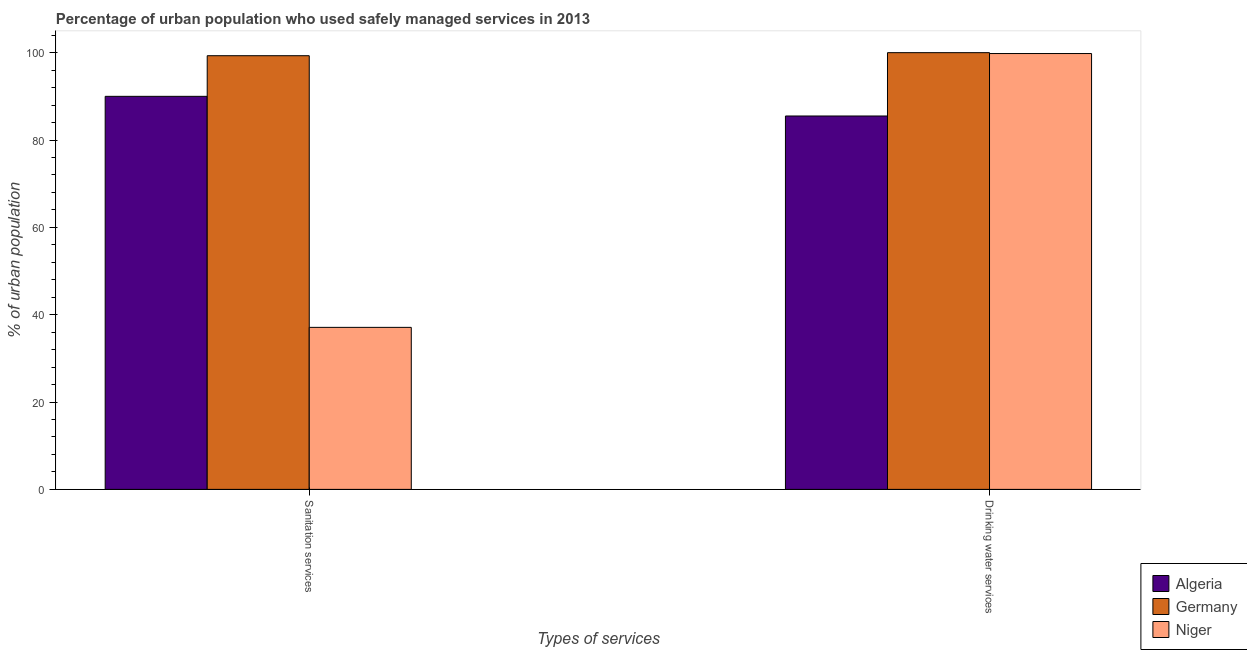How many groups of bars are there?
Make the answer very short. 2. Are the number of bars per tick equal to the number of legend labels?
Provide a short and direct response. Yes. How many bars are there on the 2nd tick from the right?
Ensure brevity in your answer.  3. What is the label of the 1st group of bars from the left?
Ensure brevity in your answer.  Sanitation services. What is the percentage of urban population who used sanitation services in Algeria?
Offer a terse response. 90. Across all countries, what is the maximum percentage of urban population who used sanitation services?
Provide a short and direct response. 99.3. Across all countries, what is the minimum percentage of urban population who used sanitation services?
Make the answer very short. 37.1. In which country was the percentage of urban population who used drinking water services maximum?
Make the answer very short. Germany. In which country was the percentage of urban population who used sanitation services minimum?
Ensure brevity in your answer.  Niger. What is the total percentage of urban population who used sanitation services in the graph?
Give a very brief answer. 226.4. What is the difference between the percentage of urban population who used drinking water services in Germany and that in Niger?
Give a very brief answer. 0.2. What is the difference between the percentage of urban population who used drinking water services in Niger and the percentage of urban population who used sanitation services in Algeria?
Provide a short and direct response. 9.8. What is the average percentage of urban population who used sanitation services per country?
Make the answer very short. 75.47. What is the ratio of the percentage of urban population who used drinking water services in Germany to that in Niger?
Your answer should be very brief. 1. What does the 1st bar from the right in Sanitation services represents?
Make the answer very short. Niger. Are all the bars in the graph horizontal?
Ensure brevity in your answer.  No. What is the difference between two consecutive major ticks on the Y-axis?
Your answer should be very brief. 20. Does the graph contain grids?
Keep it short and to the point. No. What is the title of the graph?
Provide a succinct answer. Percentage of urban population who used safely managed services in 2013. Does "Middle East & North Africa (all income levels)" appear as one of the legend labels in the graph?
Provide a short and direct response. No. What is the label or title of the X-axis?
Provide a short and direct response. Types of services. What is the label or title of the Y-axis?
Your answer should be very brief. % of urban population. What is the % of urban population in Algeria in Sanitation services?
Offer a terse response. 90. What is the % of urban population in Germany in Sanitation services?
Your answer should be very brief. 99.3. What is the % of urban population of Niger in Sanitation services?
Offer a terse response. 37.1. What is the % of urban population of Algeria in Drinking water services?
Make the answer very short. 85.5. What is the % of urban population of Germany in Drinking water services?
Your answer should be compact. 100. What is the % of urban population of Niger in Drinking water services?
Your response must be concise. 99.8. Across all Types of services, what is the maximum % of urban population in Germany?
Your response must be concise. 100. Across all Types of services, what is the maximum % of urban population of Niger?
Keep it short and to the point. 99.8. Across all Types of services, what is the minimum % of urban population of Algeria?
Your response must be concise. 85.5. Across all Types of services, what is the minimum % of urban population of Germany?
Offer a terse response. 99.3. Across all Types of services, what is the minimum % of urban population of Niger?
Keep it short and to the point. 37.1. What is the total % of urban population of Algeria in the graph?
Offer a very short reply. 175.5. What is the total % of urban population of Germany in the graph?
Ensure brevity in your answer.  199.3. What is the total % of urban population of Niger in the graph?
Your answer should be very brief. 136.9. What is the difference between the % of urban population of Algeria in Sanitation services and that in Drinking water services?
Provide a short and direct response. 4.5. What is the difference between the % of urban population in Germany in Sanitation services and that in Drinking water services?
Ensure brevity in your answer.  -0.7. What is the difference between the % of urban population of Niger in Sanitation services and that in Drinking water services?
Offer a very short reply. -62.7. What is the difference between the % of urban population of Algeria in Sanitation services and the % of urban population of Germany in Drinking water services?
Your answer should be compact. -10. What is the difference between the % of urban population in Algeria in Sanitation services and the % of urban population in Niger in Drinking water services?
Ensure brevity in your answer.  -9.8. What is the average % of urban population in Algeria per Types of services?
Your answer should be very brief. 87.75. What is the average % of urban population of Germany per Types of services?
Offer a terse response. 99.65. What is the average % of urban population in Niger per Types of services?
Keep it short and to the point. 68.45. What is the difference between the % of urban population of Algeria and % of urban population of Germany in Sanitation services?
Your response must be concise. -9.3. What is the difference between the % of urban population of Algeria and % of urban population of Niger in Sanitation services?
Ensure brevity in your answer.  52.9. What is the difference between the % of urban population of Germany and % of urban population of Niger in Sanitation services?
Your answer should be very brief. 62.2. What is the difference between the % of urban population in Algeria and % of urban population in Germany in Drinking water services?
Your response must be concise. -14.5. What is the difference between the % of urban population of Algeria and % of urban population of Niger in Drinking water services?
Keep it short and to the point. -14.3. What is the ratio of the % of urban population of Algeria in Sanitation services to that in Drinking water services?
Offer a very short reply. 1.05. What is the ratio of the % of urban population of Niger in Sanitation services to that in Drinking water services?
Offer a terse response. 0.37. What is the difference between the highest and the second highest % of urban population in Algeria?
Provide a short and direct response. 4.5. What is the difference between the highest and the second highest % of urban population of Niger?
Provide a short and direct response. 62.7. What is the difference between the highest and the lowest % of urban population of Germany?
Your answer should be very brief. 0.7. What is the difference between the highest and the lowest % of urban population of Niger?
Offer a very short reply. 62.7. 